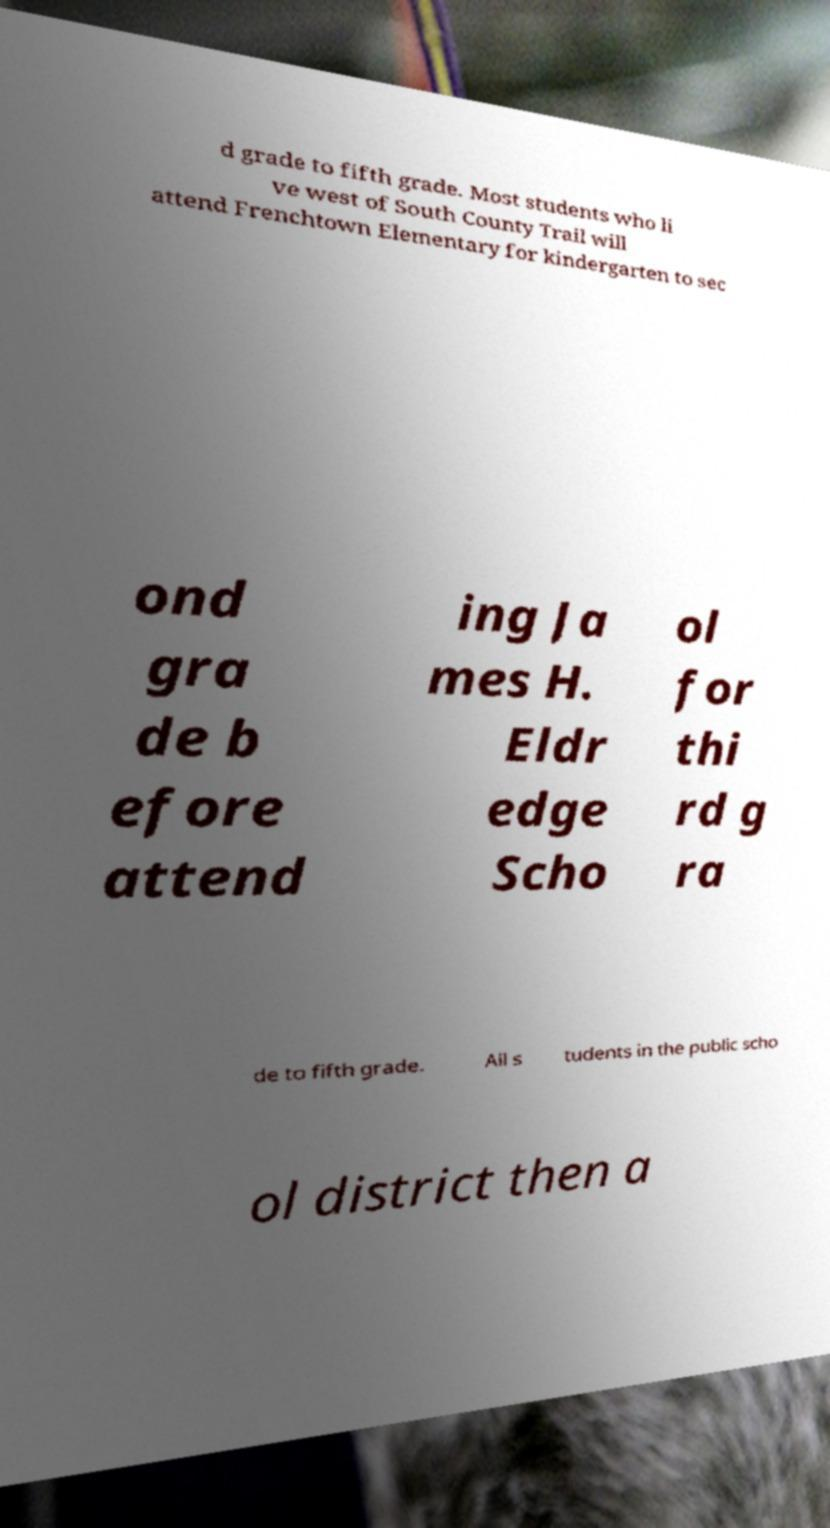I need the written content from this picture converted into text. Can you do that? d grade to fifth grade. Most students who li ve west of South County Trail will attend Frenchtown Elementary for kindergarten to sec ond gra de b efore attend ing Ja mes H. Eldr edge Scho ol for thi rd g ra de to fifth grade. All s tudents in the public scho ol district then a 